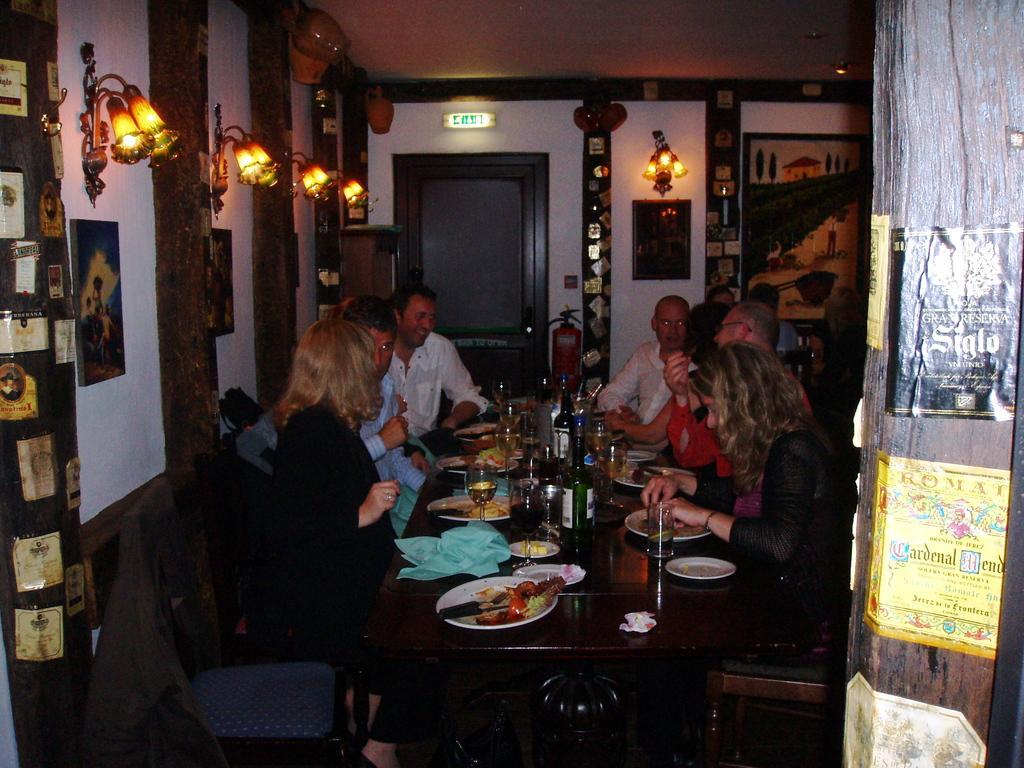In one or two sentences, can you explain what this image depicts? In this picture there are some people sitting in the chairs around the table on which some food items, glasses, plates were placed. There are men and women in this group. Behind them there are some photo frames attached to the wall and some lights here. In the background there are some lights here. 